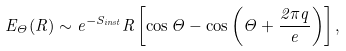<formula> <loc_0><loc_0><loc_500><loc_500>E _ { \Theta } ( R ) \sim e ^ { - S _ { i n s t } } R \left [ \cos \Theta - \cos \left ( \Theta + \frac { 2 \pi q } { e } \right ) \right ] ,</formula> 